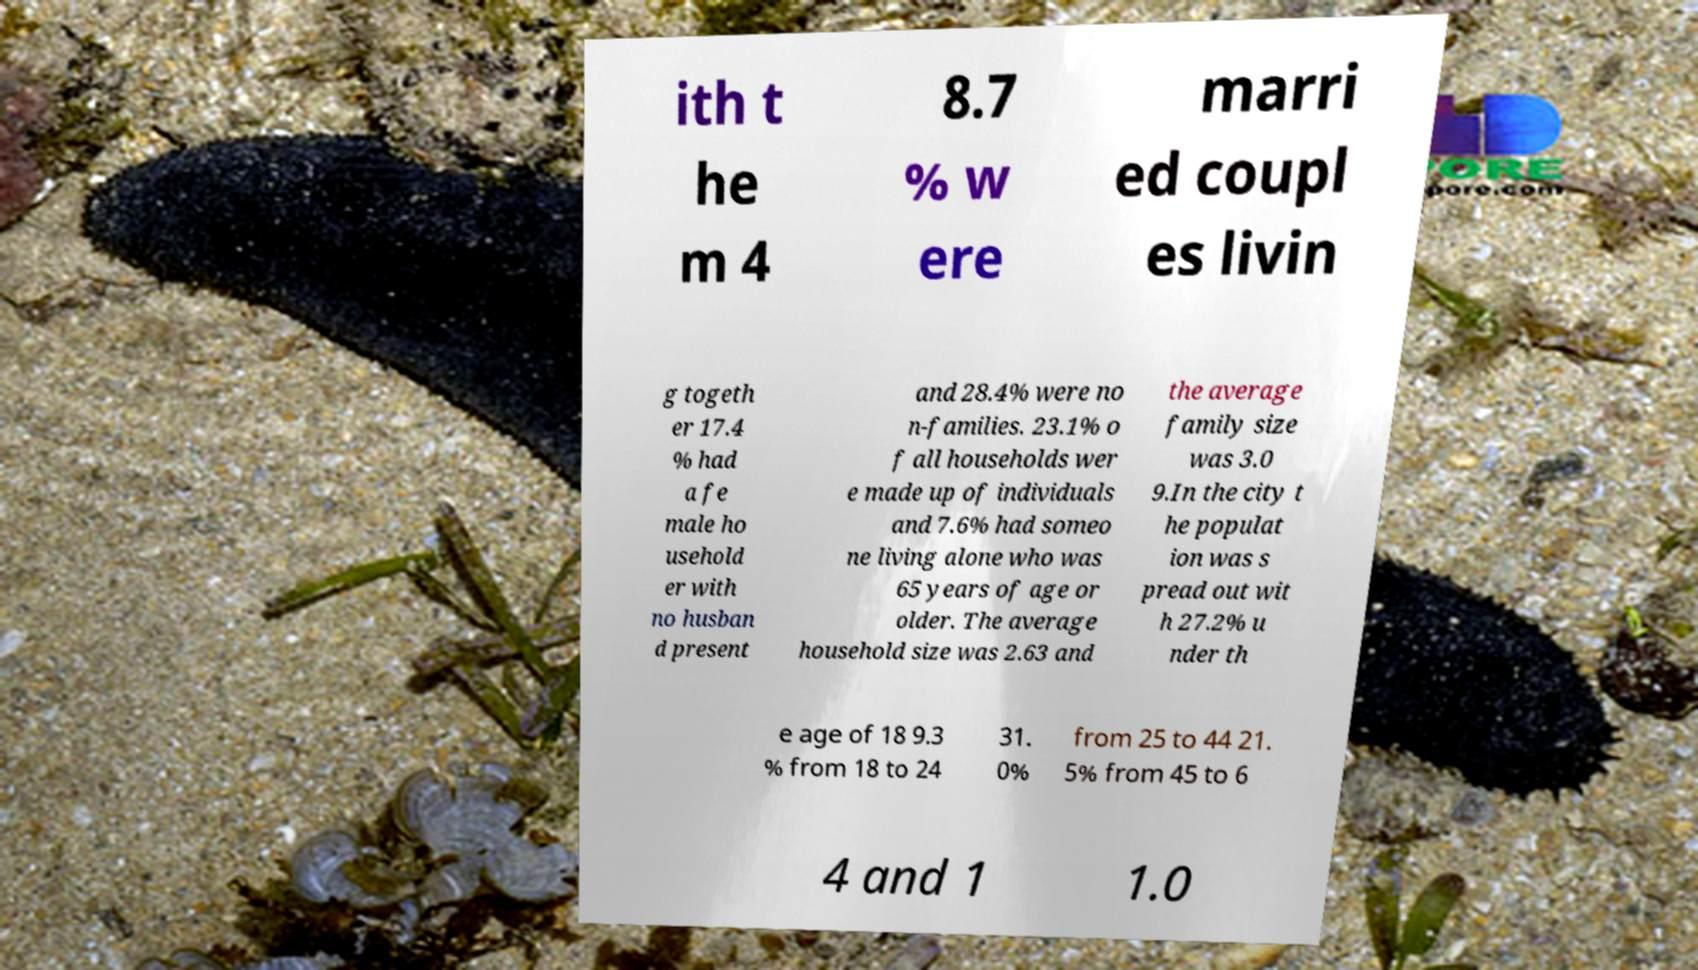Can you accurately transcribe the text from the provided image for me? ith t he m 4 8.7 % w ere marri ed coupl es livin g togeth er 17.4 % had a fe male ho usehold er with no husban d present and 28.4% were no n-families. 23.1% o f all households wer e made up of individuals and 7.6% had someo ne living alone who was 65 years of age or older. The average household size was 2.63 and the average family size was 3.0 9.In the city t he populat ion was s pread out wit h 27.2% u nder th e age of 18 9.3 % from 18 to 24 31. 0% from 25 to 44 21. 5% from 45 to 6 4 and 1 1.0 